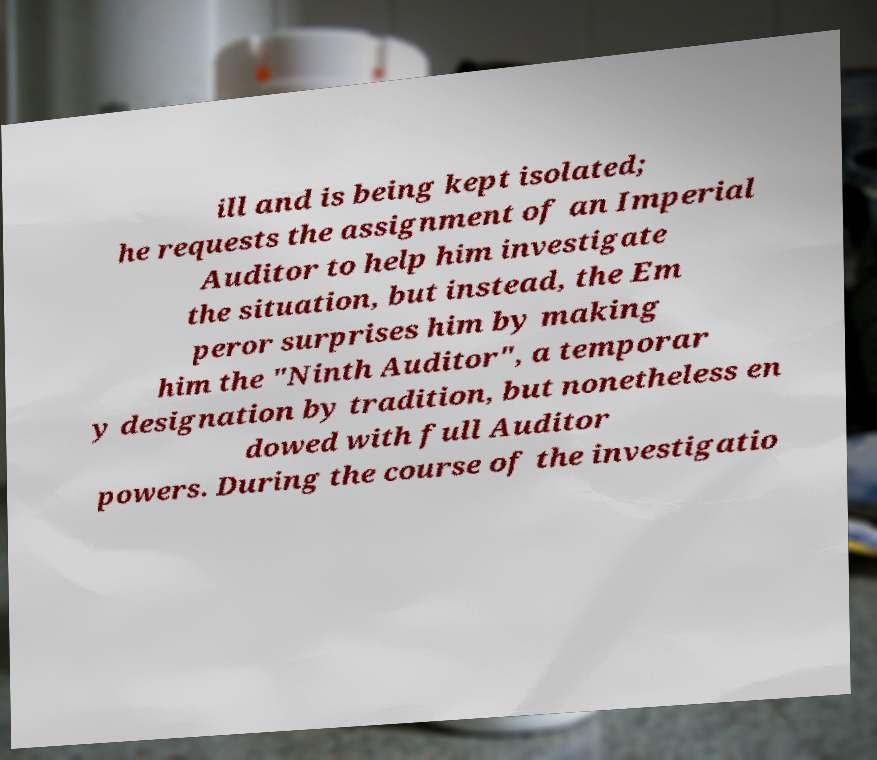Can you accurately transcribe the text from the provided image for me? ill and is being kept isolated; he requests the assignment of an Imperial Auditor to help him investigate the situation, but instead, the Em peror surprises him by making him the "Ninth Auditor", a temporar y designation by tradition, but nonetheless en dowed with full Auditor powers. During the course of the investigatio 